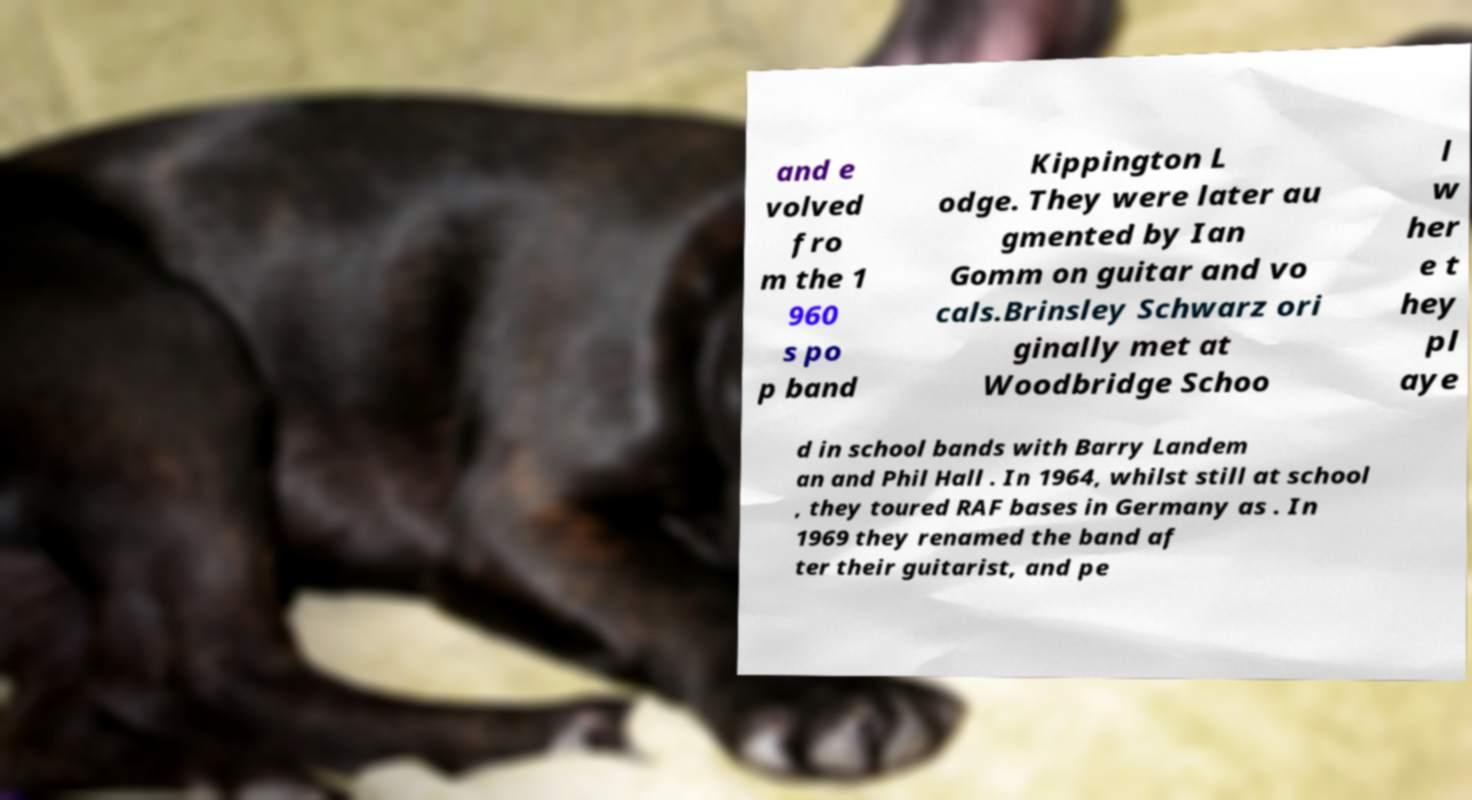What messages or text are displayed in this image? I need them in a readable, typed format. and e volved fro m the 1 960 s po p band Kippington L odge. They were later au gmented by Ian Gomm on guitar and vo cals.Brinsley Schwarz ori ginally met at Woodbridge Schoo l w her e t hey pl aye d in school bands with Barry Landem an and Phil Hall . In 1964, whilst still at school , they toured RAF bases in Germany as . In 1969 they renamed the band af ter their guitarist, and pe 